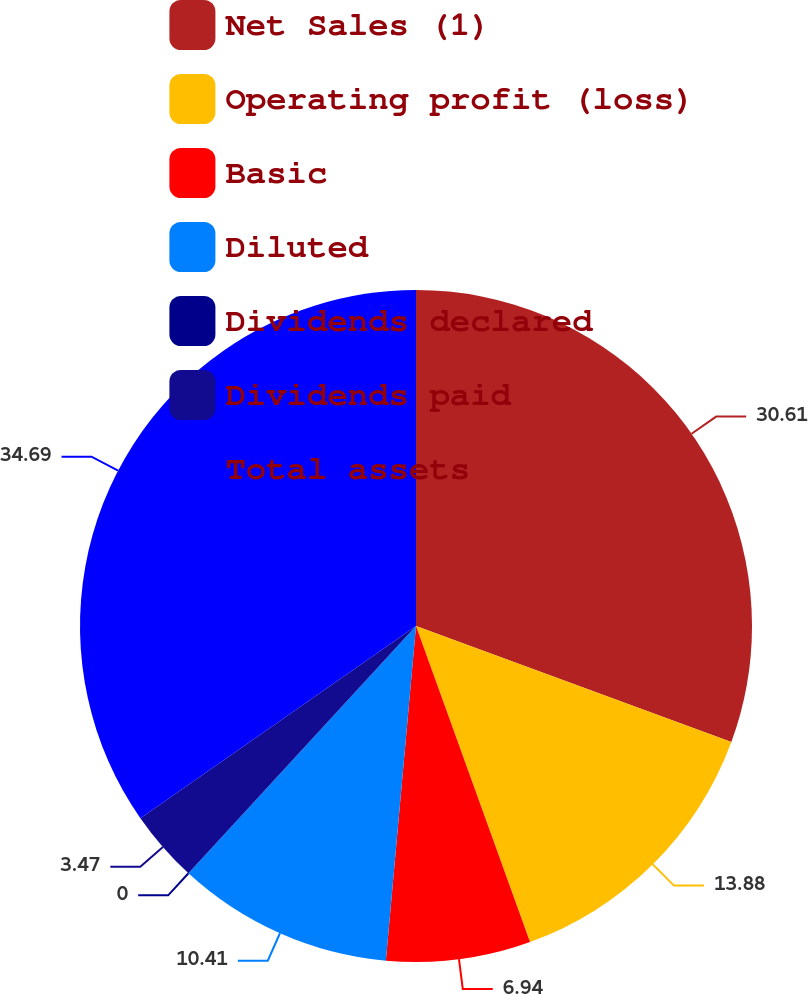Convert chart to OTSL. <chart><loc_0><loc_0><loc_500><loc_500><pie_chart><fcel>Net Sales (1)<fcel>Operating profit (loss)<fcel>Basic<fcel>Diluted<fcel>Dividends declared<fcel>Dividends paid<fcel>Total assets<nl><fcel>30.61%<fcel>13.88%<fcel>6.94%<fcel>10.41%<fcel>0.0%<fcel>3.47%<fcel>34.69%<nl></chart> 